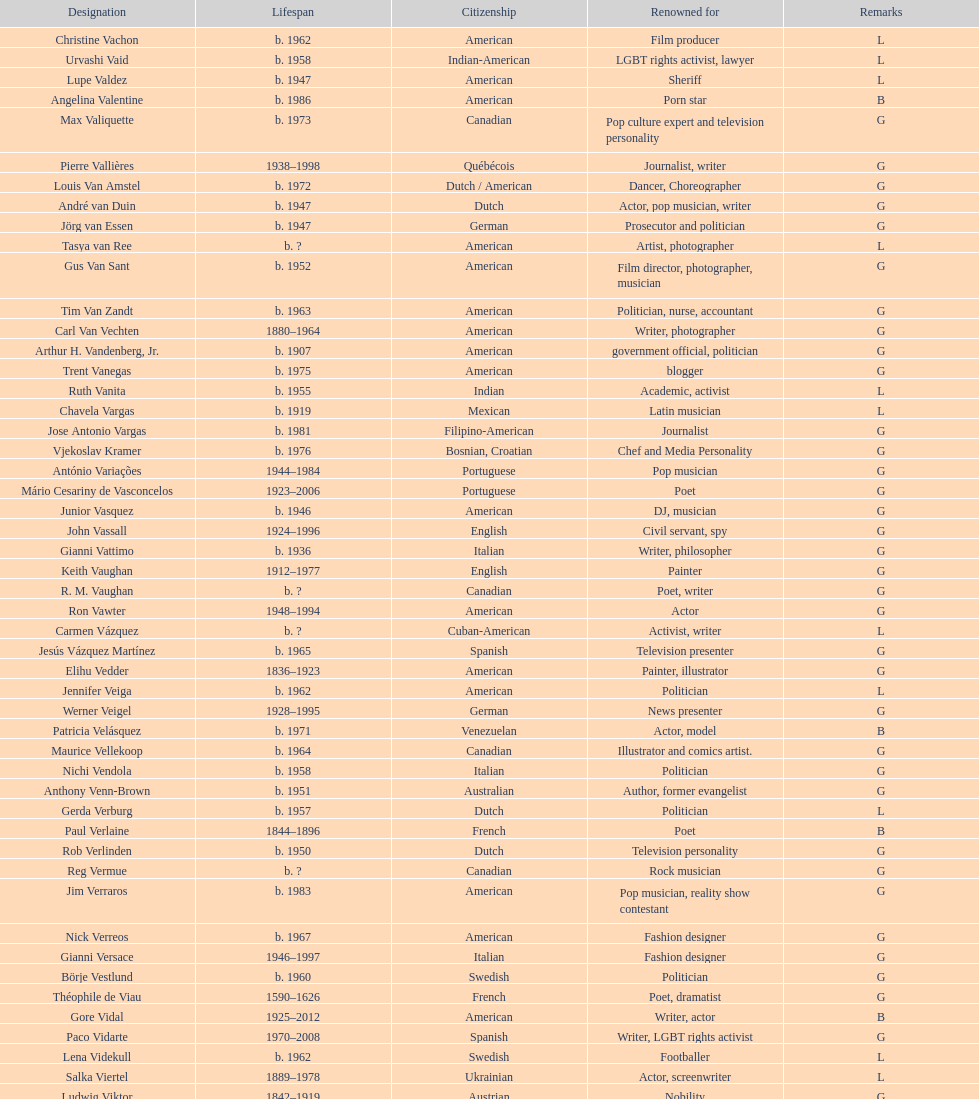How old was pierre vallieres before he died? 60. 